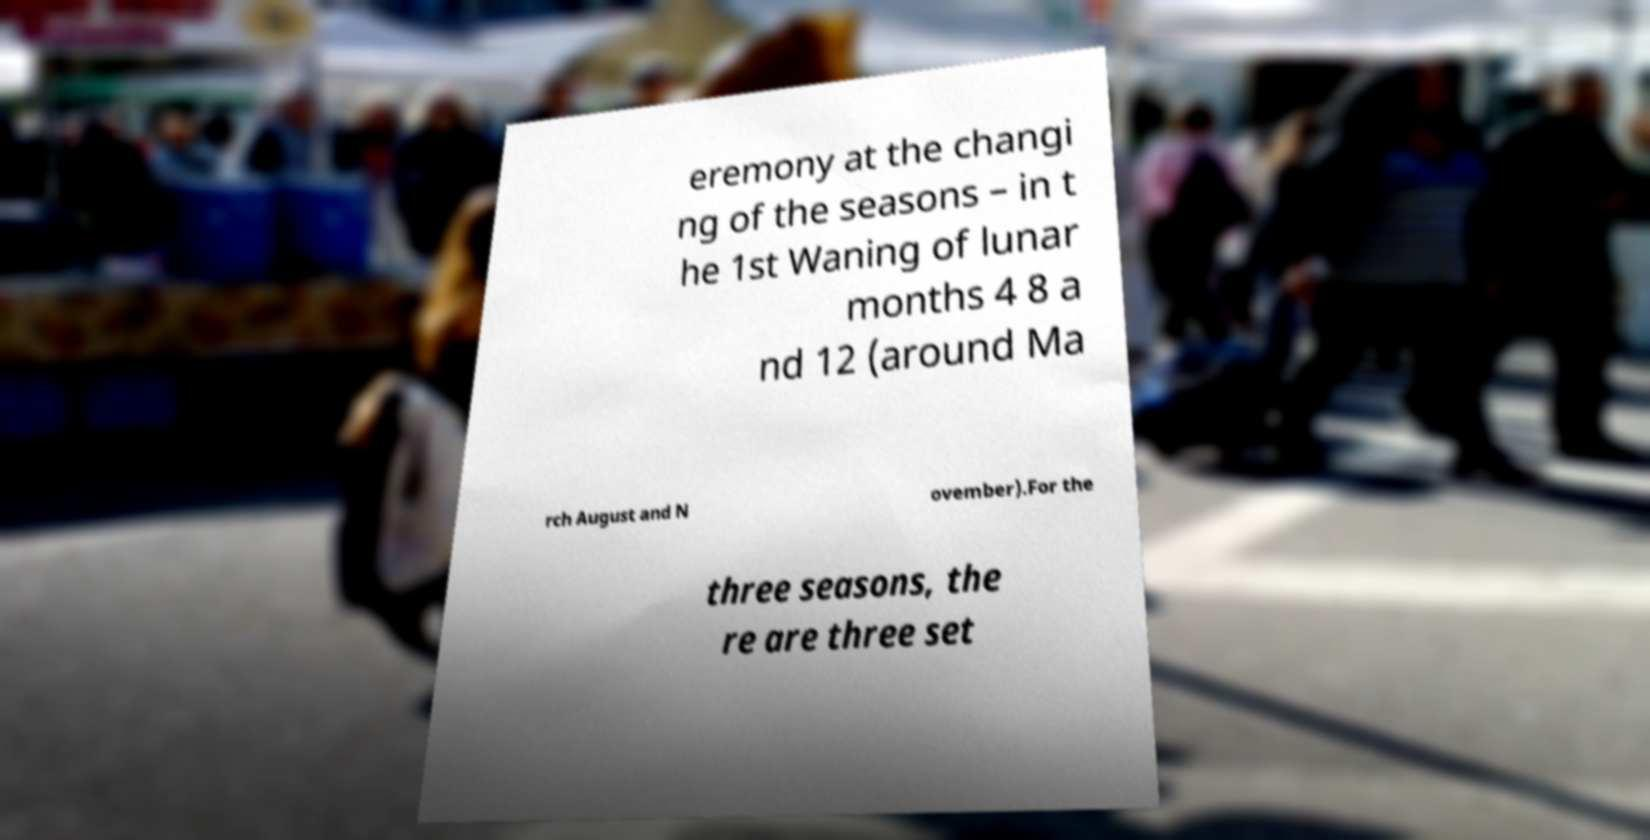Can you accurately transcribe the text from the provided image for me? eremony at the changi ng of the seasons – in t he 1st Waning of lunar months 4 8 a nd 12 (around Ma rch August and N ovember).For the three seasons, the re are three set 